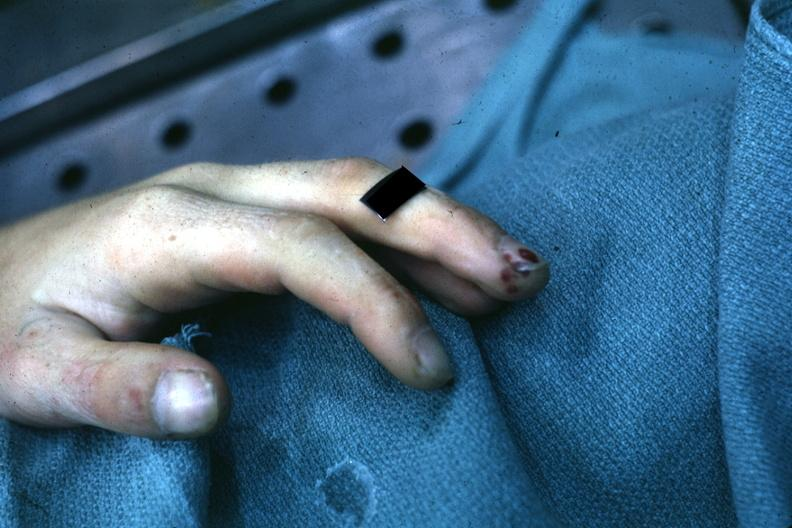does this image show very good example of focal necrotizing lesions in distal portion of digit associated with bacterial endocarditis?
Answer the question using a single word or phrase. Yes 